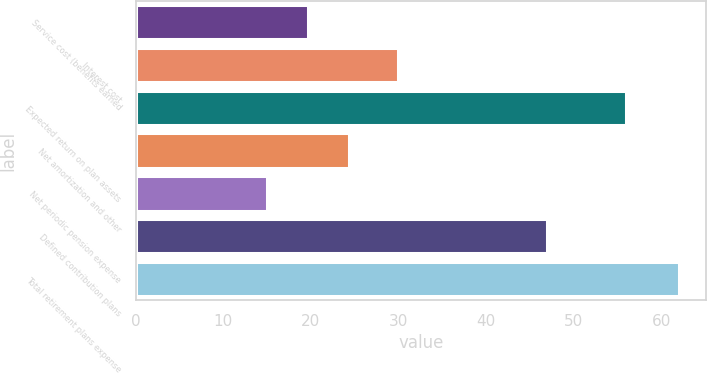Convert chart. <chart><loc_0><loc_0><loc_500><loc_500><bar_chart><fcel>Service cost (benefits earned<fcel>Interest cost<fcel>Expected return on plan assets<fcel>Net amortization and other<fcel>Net periodic pension expense<fcel>Defined contribution plans<fcel>Total retirement plans expense<nl><fcel>19.7<fcel>30<fcel>56<fcel>24.4<fcel>15<fcel>47<fcel>62<nl></chart> 